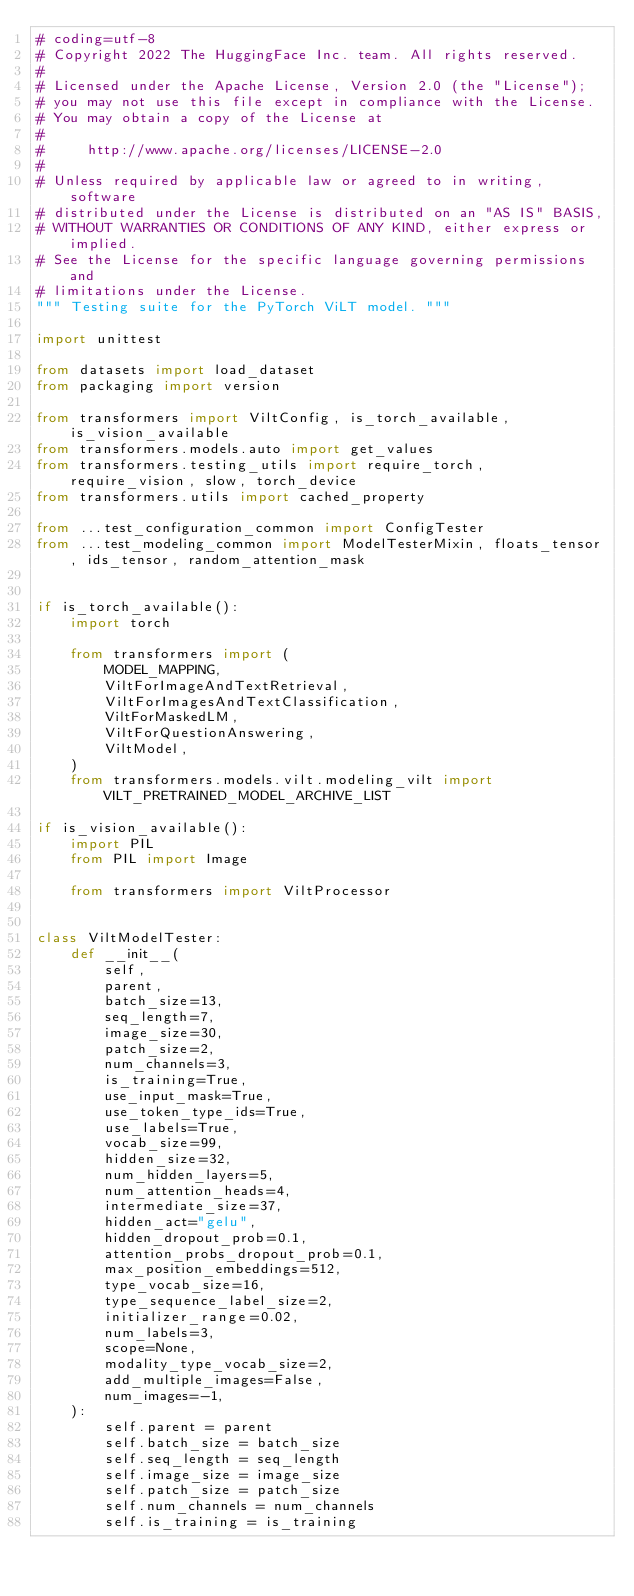<code> <loc_0><loc_0><loc_500><loc_500><_Python_># coding=utf-8
# Copyright 2022 The HuggingFace Inc. team. All rights reserved.
#
# Licensed under the Apache License, Version 2.0 (the "License");
# you may not use this file except in compliance with the License.
# You may obtain a copy of the License at
#
#     http://www.apache.org/licenses/LICENSE-2.0
#
# Unless required by applicable law or agreed to in writing, software
# distributed under the License is distributed on an "AS IS" BASIS,
# WITHOUT WARRANTIES OR CONDITIONS OF ANY KIND, either express or implied.
# See the License for the specific language governing permissions and
# limitations under the License.
""" Testing suite for the PyTorch ViLT model. """

import unittest

from datasets import load_dataset
from packaging import version

from transformers import ViltConfig, is_torch_available, is_vision_available
from transformers.models.auto import get_values
from transformers.testing_utils import require_torch, require_vision, slow, torch_device
from transformers.utils import cached_property

from ...test_configuration_common import ConfigTester
from ...test_modeling_common import ModelTesterMixin, floats_tensor, ids_tensor, random_attention_mask


if is_torch_available():
    import torch

    from transformers import (
        MODEL_MAPPING,
        ViltForImageAndTextRetrieval,
        ViltForImagesAndTextClassification,
        ViltForMaskedLM,
        ViltForQuestionAnswering,
        ViltModel,
    )
    from transformers.models.vilt.modeling_vilt import VILT_PRETRAINED_MODEL_ARCHIVE_LIST

if is_vision_available():
    import PIL
    from PIL import Image

    from transformers import ViltProcessor


class ViltModelTester:
    def __init__(
        self,
        parent,
        batch_size=13,
        seq_length=7,
        image_size=30,
        patch_size=2,
        num_channels=3,
        is_training=True,
        use_input_mask=True,
        use_token_type_ids=True,
        use_labels=True,
        vocab_size=99,
        hidden_size=32,
        num_hidden_layers=5,
        num_attention_heads=4,
        intermediate_size=37,
        hidden_act="gelu",
        hidden_dropout_prob=0.1,
        attention_probs_dropout_prob=0.1,
        max_position_embeddings=512,
        type_vocab_size=16,
        type_sequence_label_size=2,
        initializer_range=0.02,
        num_labels=3,
        scope=None,
        modality_type_vocab_size=2,
        add_multiple_images=False,
        num_images=-1,
    ):
        self.parent = parent
        self.batch_size = batch_size
        self.seq_length = seq_length
        self.image_size = image_size
        self.patch_size = patch_size
        self.num_channels = num_channels
        self.is_training = is_training</code> 